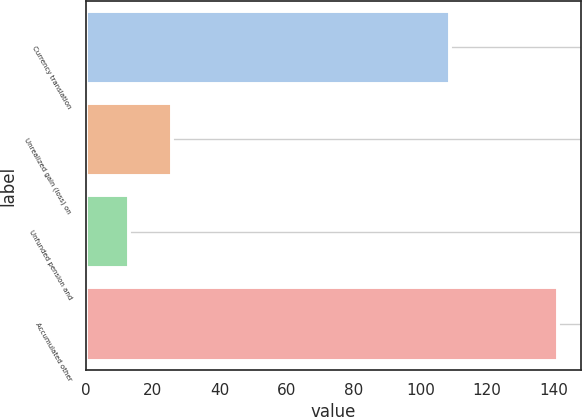<chart> <loc_0><loc_0><loc_500><loc_500><bar_chart><fcel>Currency translation<fcel>Unrealized gain (loss) on<fcel>Unfunded pension and<fcel>Accumulated other<nl><fcel>109<fcel>25.8<fcel>13<fcel>141<nl></chart> 